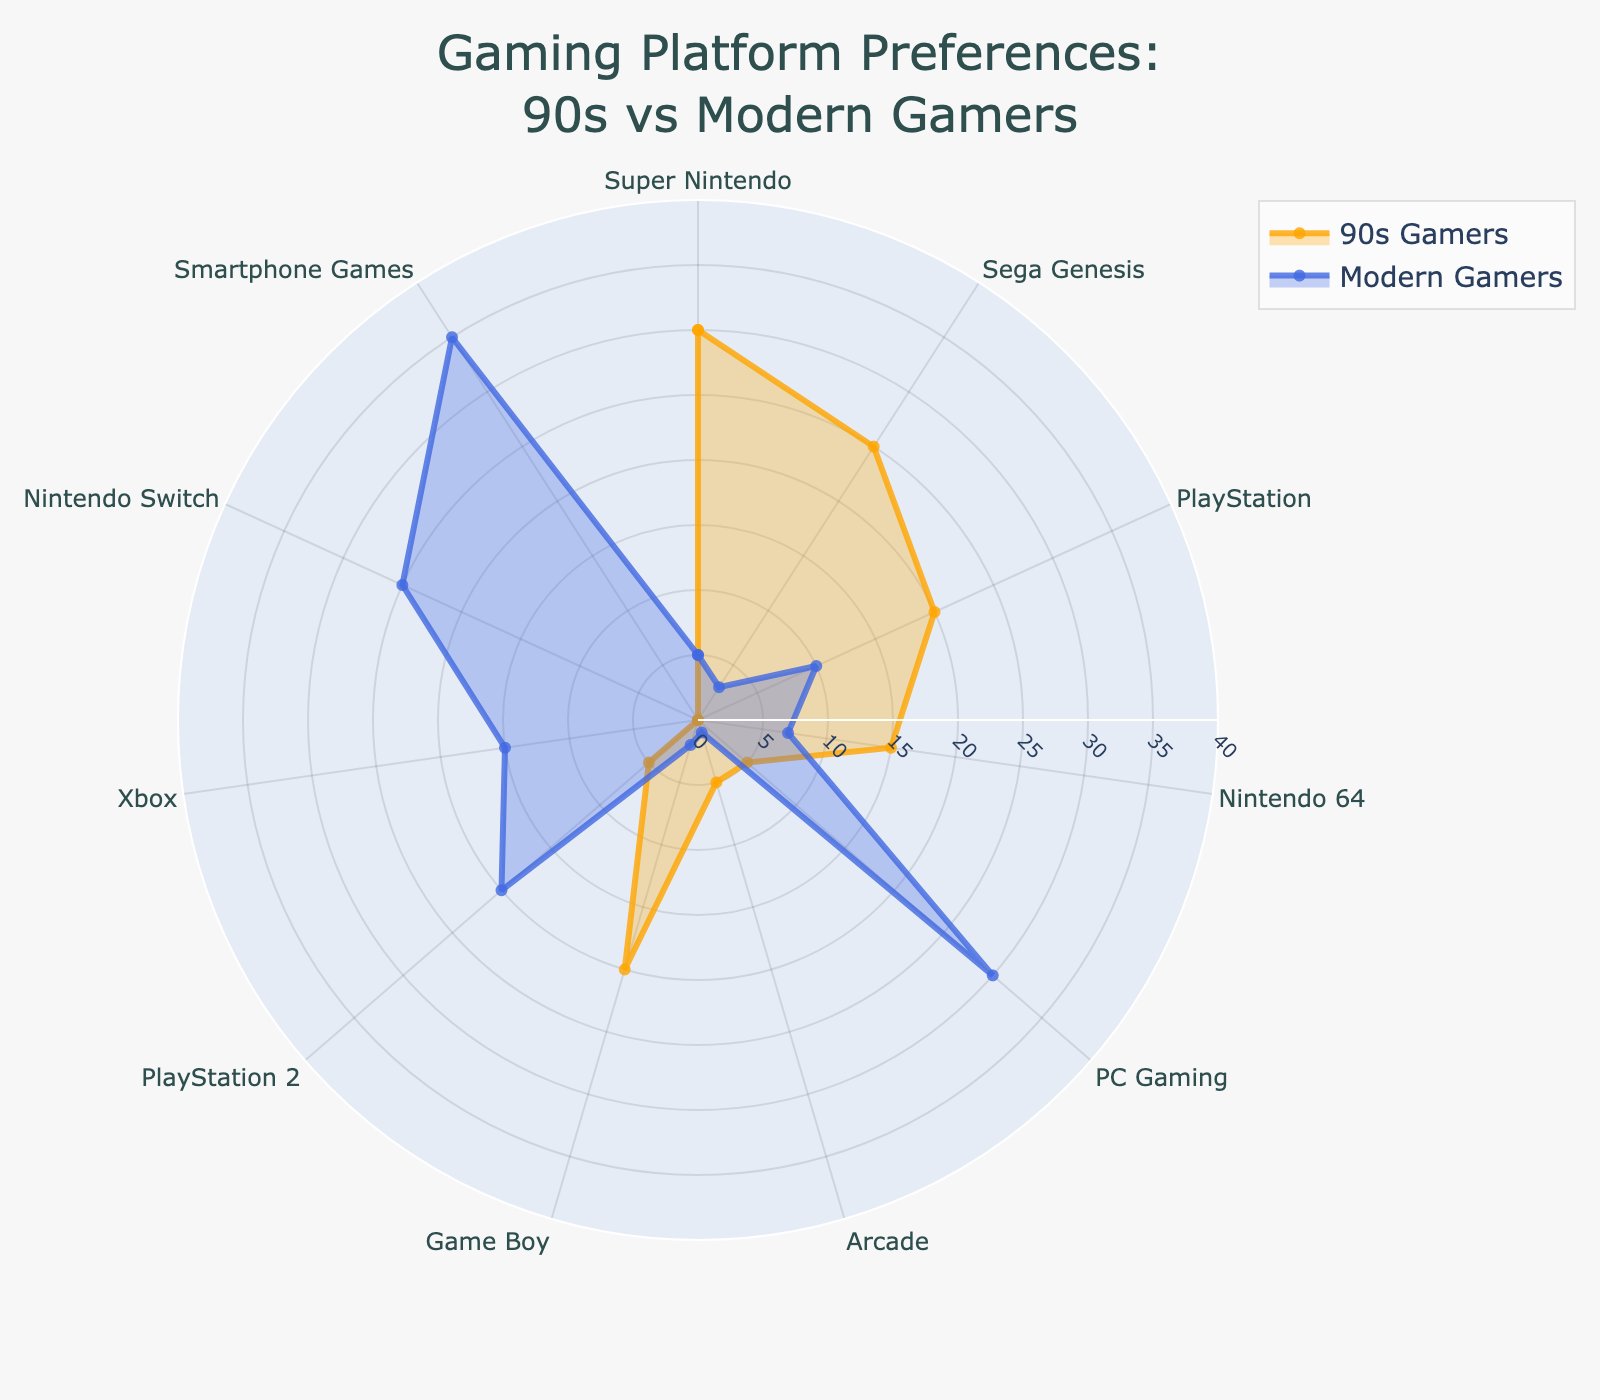What percentage of 90s gamers preferred Super Nintendo? Referring to the radar plot, we can see that the proportion of 90s gamers who preferred Super Nintendo is shown on one of the axes, where the value reaches 30%.
Answer: 30% What is the difference in preference for PC Gaming between 90s gamers and modern gamers? From the radar chart, 90s gamers' preference for PC Gaming is 5%, while modern gamers' preference is 30%. Subtracting these gives us a difference of 30% - 5% = 25%.
Answer: 25% Which platform has the highest preference among modern gamers? On the radar chart, the platform with the highest value for modern gamers is clearly marked. Smartphone Games stand out with a preference of 35%.
Answer: Smartphone Games How does the preference for PlayStation compare between 90s gamers and modern gamers? Observing the radar chart, 90s gamers' preference for PlayStation is 20%, while modern gamers' preference is 10%. Comparatively, the preference in the 90s is higher.
Answer: Higher for 90s gamers What is the average preference for Game Boy among 90s gamers and modern gamers? The preferences for Game Boy are 20% for 90s gamers and 2% for modern gamers. The average is calculated as (20% + 2%) / 2 = 11%.
Answer: 11% Name two platforms that 90s gamers preferred more than modern gamers. Looking at the radar chart, Super Nintendo and Sega Genesis stand out as having higher preferences among 90s gamers compared to modern gamers.
Answer: Super Nintendo, Sega Genesis Which platform has no preference among 90s gamers but has preference among modern gamers? From the radar chart, both Xbox and Nintendo Switch have 0% preference among 90s gamers but have significant preferences among modern gamers, with Xbox at 15% and Nintendo Switch at 25%.
Answer: Xbox, Nintendo Switch What is the combined preference for Arcade and Game Boy among 90s gamers? The radar chart shows Arcade at 5% and Game Boy at 20% for 90s gamers. Summing these gives 5% + 20% = 25%.
Answer: 25% Which platform saw a significant increase in preference from 90s gamers to modern gamers, particularly for PlayStation 2? Observing the chart, we see PlayStation 2 had a preference of 5% among 90s gamers, while it increased to 20% among modern gamers. This is a significant increase.
Answer: PlayStation 2 Compare the preference for Nintendo 64 between 90s gamers and modern gamers. The radar chart shows Nintendo 64 with 15% preference among 90s gamers and 7% among modern gamers. The preference is higher for 90s gamers.
Answer: Higher for 90s gamers 